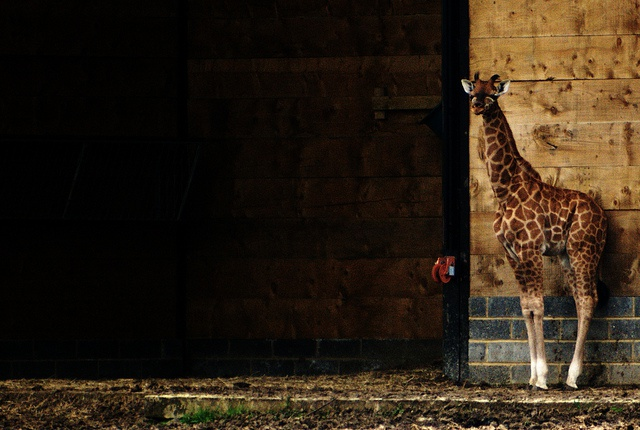Describe the objects in this image and their specific colors. I can see a giraffe in black, maroon, and brown tones in this image. 